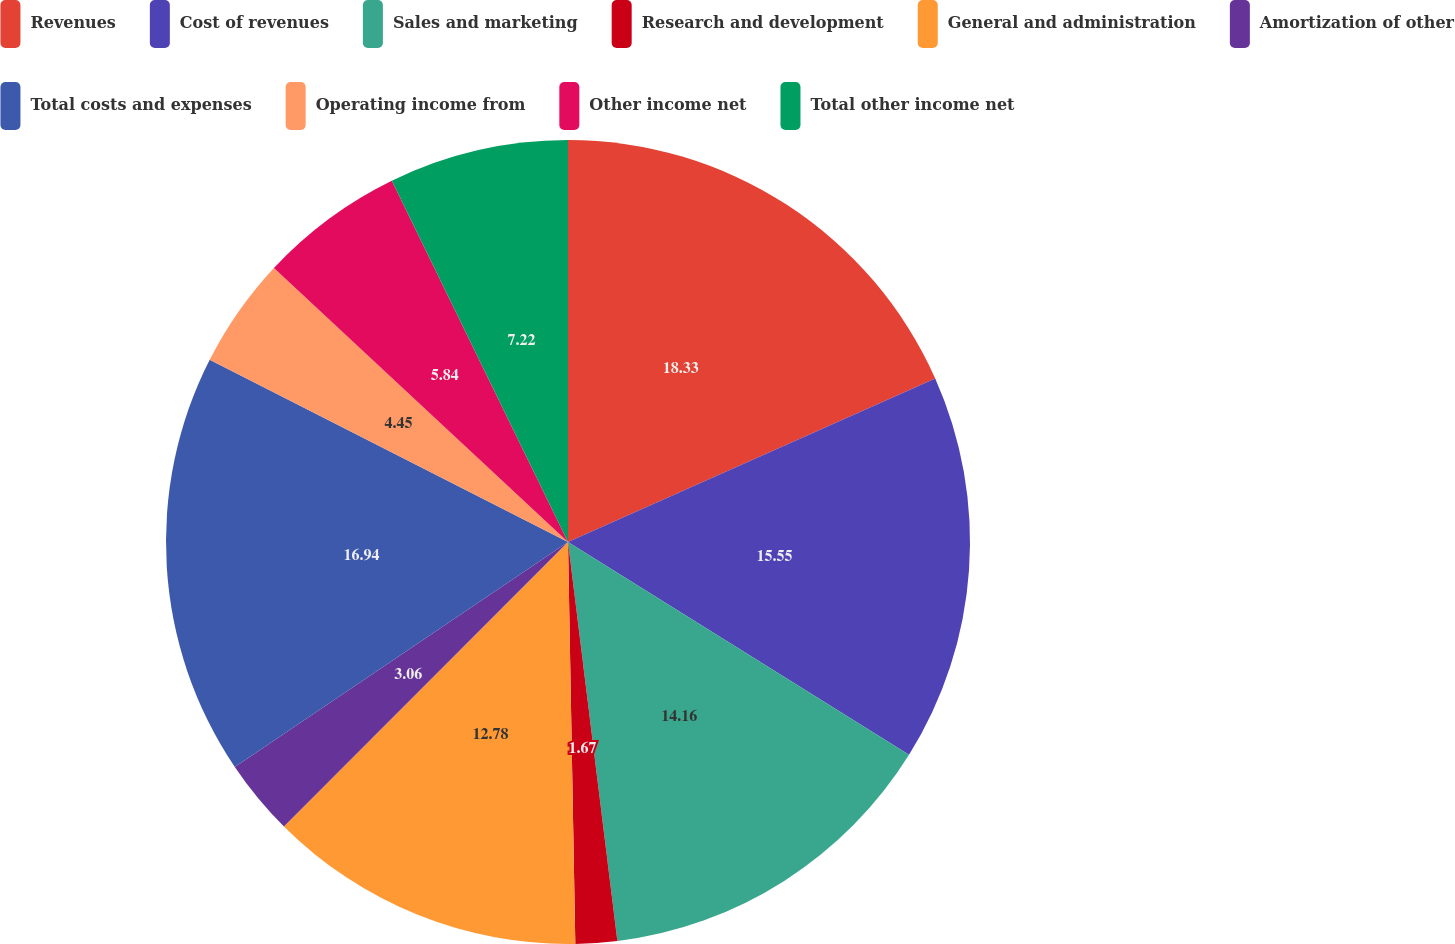Convert chart to OTSL. <chart><loc_0><loc_0><loc_500><loc_500><pie_chart><fcel>Revenues<fcel>Cost of revenues<fcel>Sales and marketing<fcel>Research and development<fcel>General and administration<fcel>Amortization of other<fcel>Total costs and expenses<fcel>Operating income from<fcel>Other income net<fcel>Total other income net<nl><fcel>18.33%<fcel>15.55%<fcel>14.16%<fcel>1.67%<fcel>12.78%<fcel>3.06%<fcel>16.94%<fcel>4.45%<fcel>5.84%<fcel>7.22%<nl></chart> 